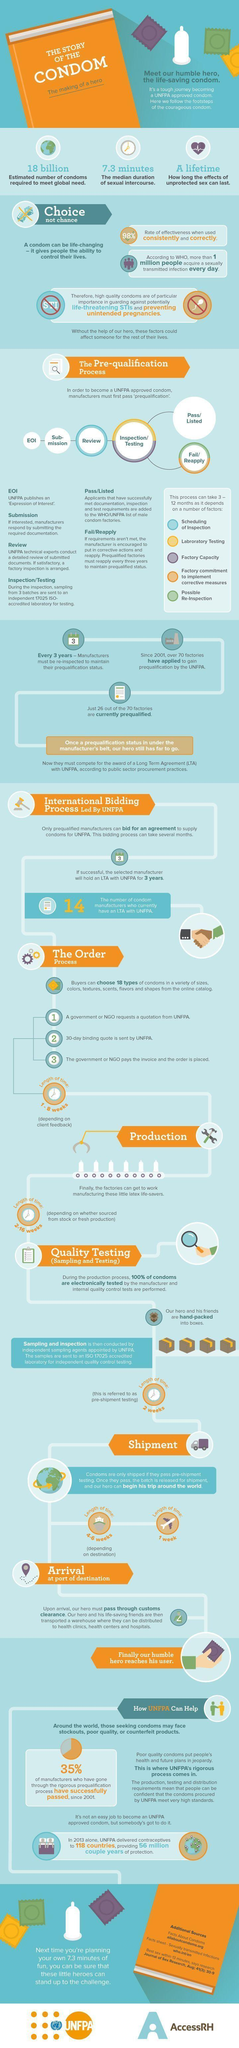Draw attention to some important aspects in this diagram. Since 2001, 37.14% of factories that have applied have been prequalified. Since 2001, a total of 40 manufacturers have applied for a Long Term Agreement (LTA) with the United Nations Population Fund (UNFPA). 